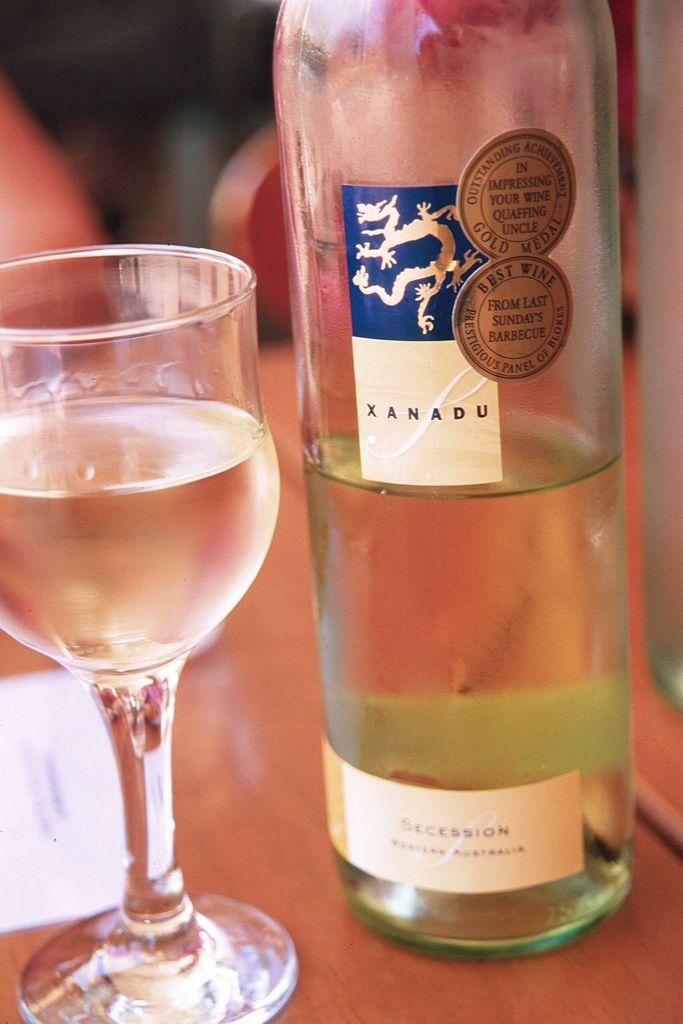What is one of the objects visible in the image? There is a bottle in the image. What other object can be seen in the image? There is a glass in the image. What is the color of the surface on which the objects are placed? The objects are placed on a brown color surface. Can you describe the background of the image? The background of the image is blurred. What type of reward is being offered in the image? There is no reward being offered in the image; it only features a bottle and a glass on a brown surface with a blurred background. 